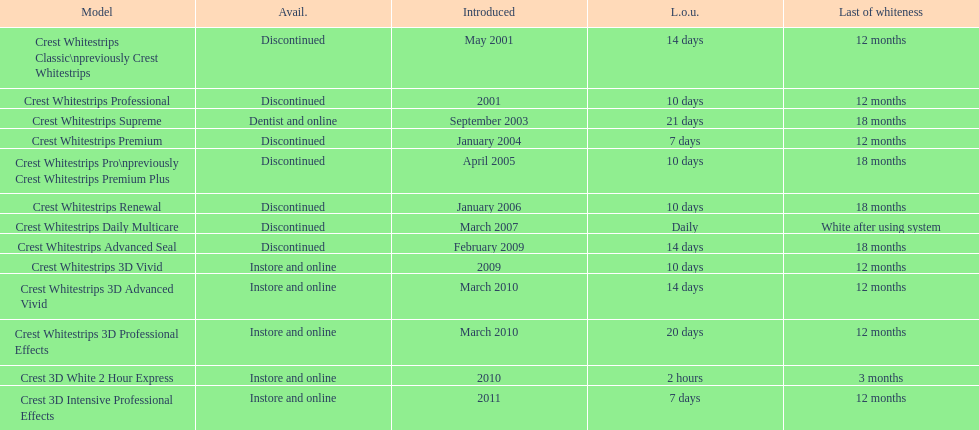How many products have been discontinued? 7. 